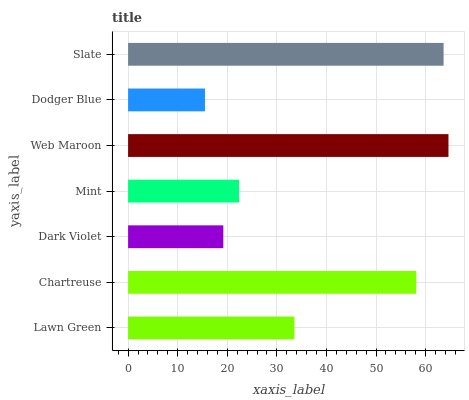Is Dodger Blue the minimum?
Answer yes or no. Yes. Is Web Maroon the maximum?
Answer yes or no. Yes. Is Chartreuse the minimum?
Answer yes or no. No. Is Chartreuse the maximum?
Answer yes or no. No. Is Chartreuse greater than Lawn Green?
Answer yes or no. Yes. Is Lawn Green less than Chartreuse?
Answer yes or no. Yes. Is Lawn Green greater than Chartreuse?
Answer yes or no. No. Is Chartreuse less than Lawn Green?
Answer yes or no. No. Is Lawn Green the high median?
Answer yes or no. Yes. Is Lawn Green the low median?
Answer yes or no. Yes. Is Mint the high median?
Answer yes or no. No. Is Chartreuse the low median?
Answer yes or no. No. 